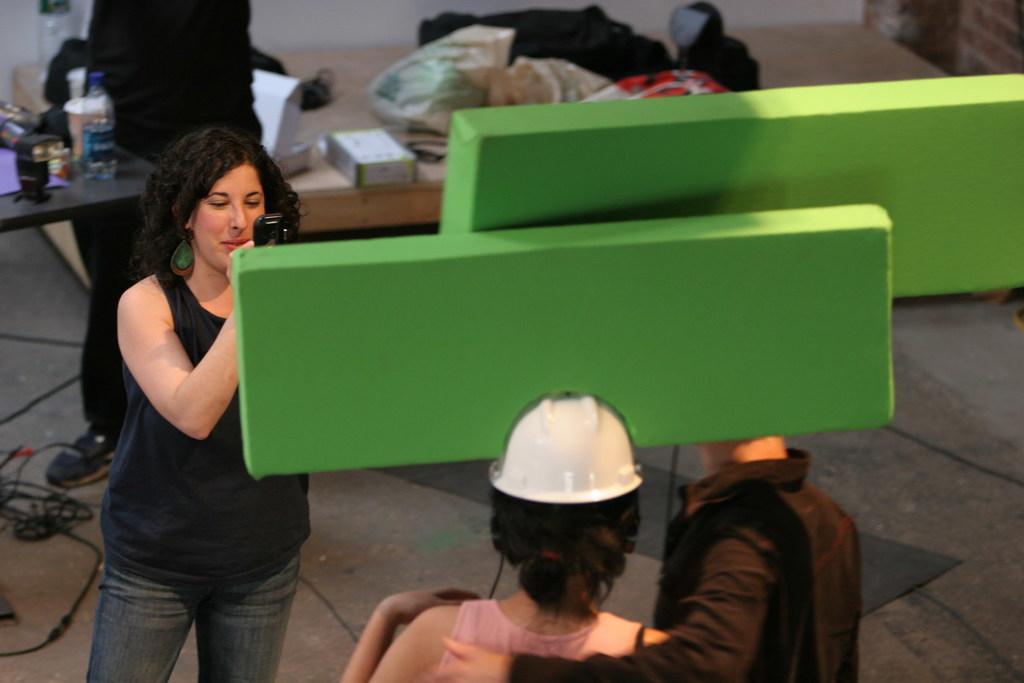Could you give a brief overview of what you see in this image? In the image we can see there is a woman who is holding a camera in front of her there are two people who are standing and at the back there is a person who is standing and beside him there is a table on which a water bottle is kept. 